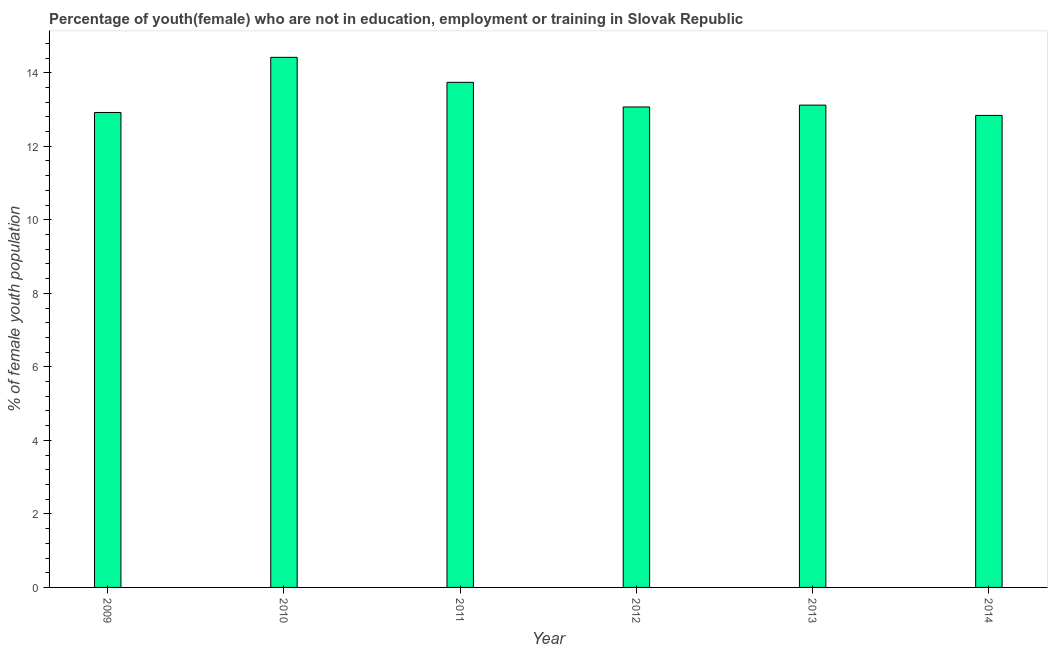Does the graph contain any zero values?
Ensure brevity in your answer.  No. What is the title of the graph?
Your answer should be very brief. Percentage of youth(female) who are not in education, employment or training in Slovak Republic. What is the label or title of the Y-axis?
Ensure brevity in your answer.  % of female youth population. What is the unemployed female youth population in 2013?
Provide a succinct answer. 13.12. Across all years, what is the maximum unemployed female youth population?
Give a very brief answer. 14.42. Across all years, what is the minimum unemployed female youth population?
Your response must be concise. 12.84. In which year was the unemployed female youth population maximum?
Ensure brevity in your answer.  2010. In which year was the unemployed female youth population minimum?
Give a very brief answer. 2014. What is the sum of the unemployed female youth population?
Ensure brevity in your answer.  80.11. What is the average unemployed female youth population per year?
Offer a terse response. 13.35. What is the median unemployed female youth population?
Your answer should be compact. 13.09. In how many years, is the unemployed female youth population greater than 4.4 %?
Provide a short and direct response. 6. Do a majority of the years between 2009 and 2011 (inclusive) have unemployed female youth population greater than 10.8 %?
Make the answer very short. Yes. What is the ratio of the unemployed female youth population in 2009 to that in 2011?
Provide a short and direct response. 0.94. Is the difference between the unemployed female youth population in 2009 and 2014 greater than the difference between any two years?
Provide a succinct answer. No. What is the difference between the highest and the second highest unemployed female youth population?
Provide a succinct answer. 0.68. Is the sum of the unemployed female youth population in 2012 and 2013 greater than the maximum unemployed female youth population across all years?
Provide a short and direct response. Yes. What is the difference between the highest and the lowest unemployed female youth population?
Provide a short and direct response. 1.58. In how many years, is the unemployed female youth population greater than the average unemployed female youth population taken over all years?
Give a very brief answer. 2. Are all the bars in the graph horizontal?
Give a very brief answer. No. What is the difference between two consecutive major ticks on the Y-axis?
Provide a succinct answer. 2. What is the % of female youth population in 2009?
Your answer should be compact. 12.92. What is the % of female youth population of 2010?
Your answer should be very brief. 14.42. What is the % of female youth population of 2011?
Provide a short and direct response. 13.74. What is the % of female youth population in 2012?
Make the answer very short. 13.07. What is the % of female youth population in 2013?
Your response must be concise. 13.12. What is the % of female youth population in 2014?
Keep it short and to the point. 12.84. What is the difference between the % of female youth population in 2009 and 2010?
Your answer should be very brief. -1.5. What is the difference between the % of female youth population in 2009 and 2011?
Offer a terse response. -0.82. What is the difference between the % of female youth population in 2009 and 2013?
Provide a short and direct response. -0.2. What is the difference between the % of female youth population in 2009 and 2014?
Provide a short and direct response. 0.08. What is the difference between the % of female youth population in 2010 and 2011?
Your response must be concise. 0.68. What is the difference between the % of female youth population in 2010 and 2012?
Provide a short and direct response. 1.35. What is the difference between the % of female youth population in 2010 and 2014?
Offer a very short reply. 1.58. What is the difference between the % of female youth population in 2011 and 2012?
Give a very brief answer. 0.67. What is the difference between the % of female youth population in 2011 and 2013?
Keep it short and to the point. 0.62. What is the difference between the % of female youth population in 2012 and 2013?
Provide a short and direct response. -0.05. What is the difference between the % of female youth population in 2012 and 2014?
Provide a succinct answer. 0.23. What is the difference between the % of female youth population in 2013 and 2014?
Keep it short and to the point. 0.28. What is the ratio of the % of female youth population in 2009 to that in 2010?
Make the answer very short. 0.9. What is the ratio of the % of female youth population in 2010 to that in 2011?
Offer a very short reply. 1.05. What is the ratio of the % of female youth population in 2010 to that in 2012?
Keep it short and to the point. 1.1. What is the ratio of the % of female youth population in 2010 to that in 2013?
Your answer should be very brief. 1.1. What is the ratio of the % of female youth population in 2010 to that in 2014?
Your answer should be very brief. 1.12. What is the ratio of the % of female youth population in 2011 to that in 2012?
Make the answer very short. 1.05. What is the ratio of the % of female youth population in 2011 to that in 2013?
Offer a very short reply. 1.05. What is the ratio of the % of female youth population in 2011 to that in 2014?
Provide a succinct answer. 1.07. 